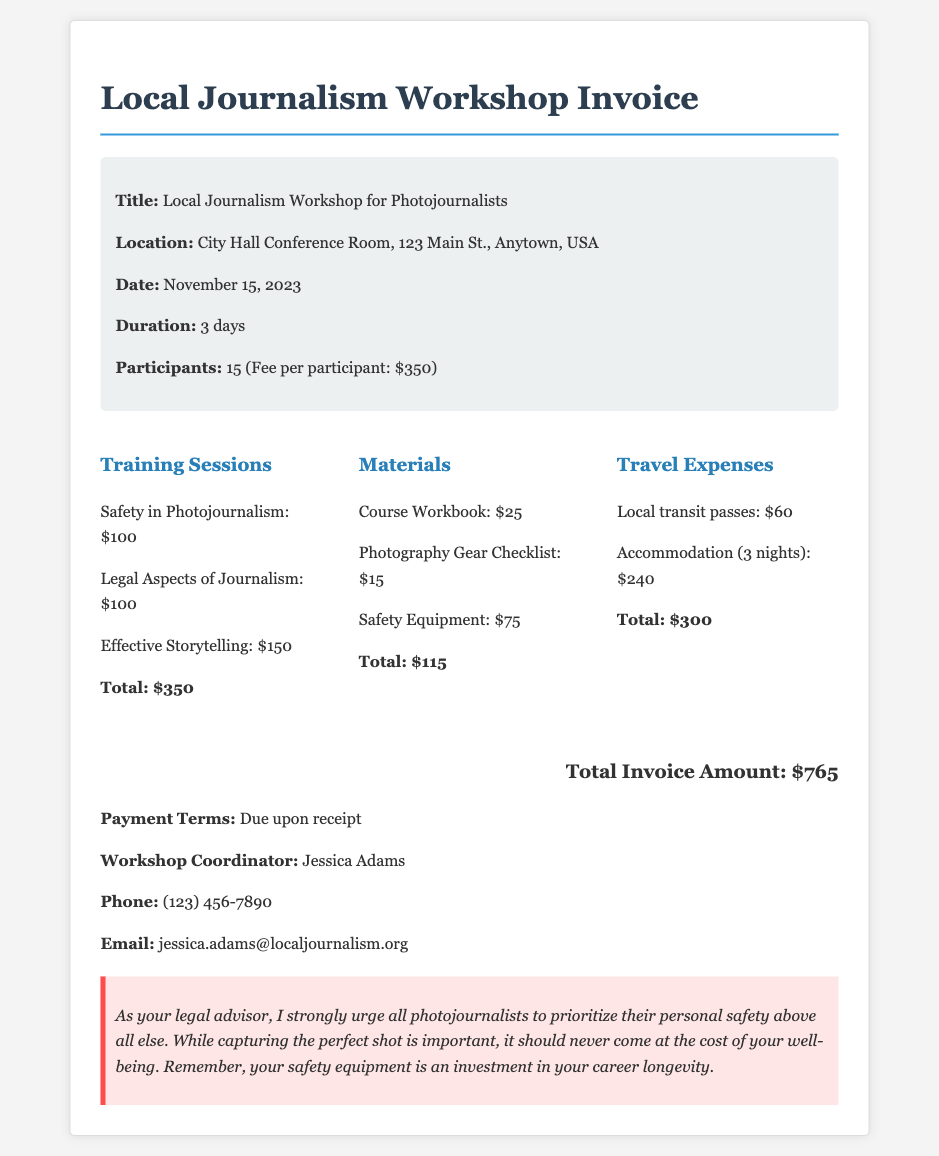what is the total invoice amount? The total invoice amount is clearly stated at the end of the document.
Answer: $765 what is the location of the workshop? The location is provided in the workshop details section of the document.
Answer: City Hall Conference Room, 123 Main St., Anytown, USA how many participants were there? The number of participants is mentioned in the workshop details.
Answer: 15 what is the duration of the workshop? The duration is specified in the workshop details section.
Answer: 3 days what is the cost of safety equipment? The cost of safety equipment is listed under the materials cost breakdown.
Answer: $75 what are the payment terms? The payment terms are provided at the end of the document.
Answer: Due upon receipt who is the workshop coordinator? The coordinator's name is provided in the contact information section.
Answer: Jessica Adams how much was spent on travel expenses? The total cost for travel expenses is provided in the cost breakdown section.
Answer: $300 what is the cost of the effective storytelling training session? The cost for this specific training session is mentioned in the training sessions cost section.
Answer: $150 